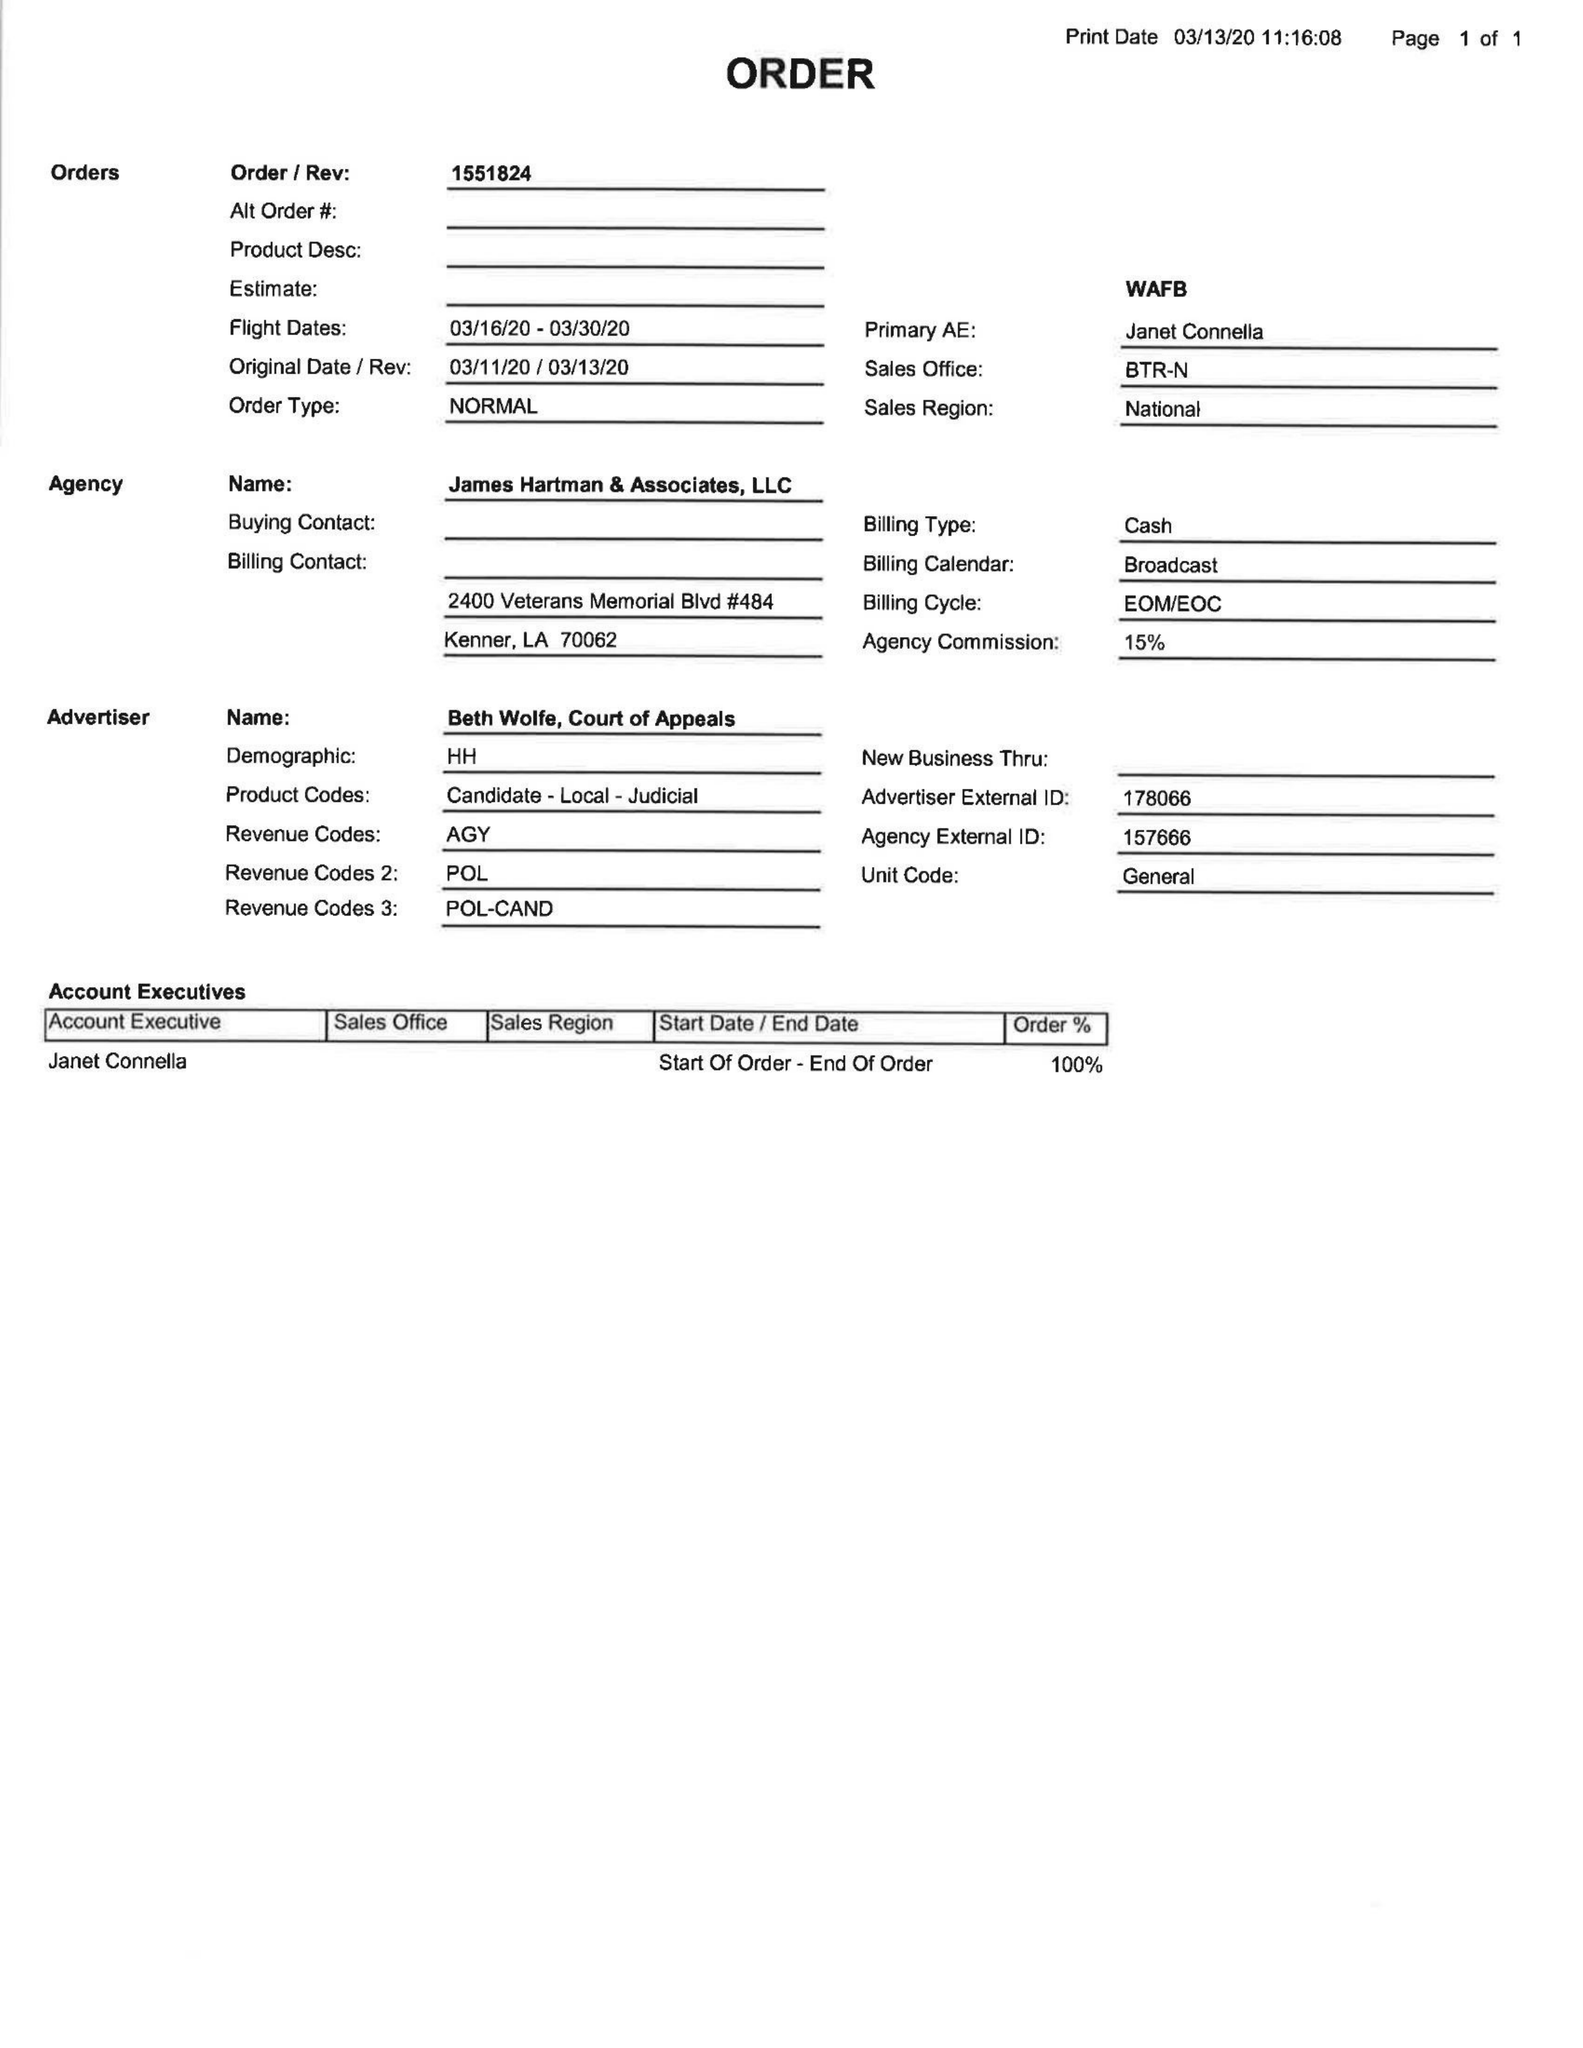What is the value for the flight_from?
Answer the question using a single word or phrase. 03/16/20 